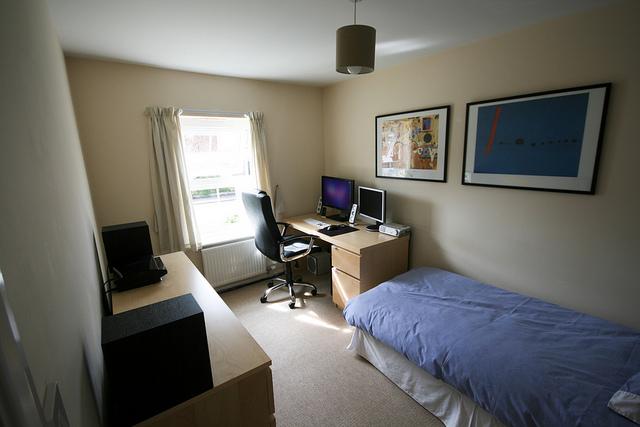Are there hanging shower curtains in this room?
Answer briefly. No. Is the window opened?
Quick response, please. Yes. What is on the bed?
Give a very brief answer. Blanket. Does this room look cold with no personal touches?
Write a very short answer. Yes. Is the lamp on?
Short answer required. No. Is this a bedroom?
Answer briefly. Yes. 